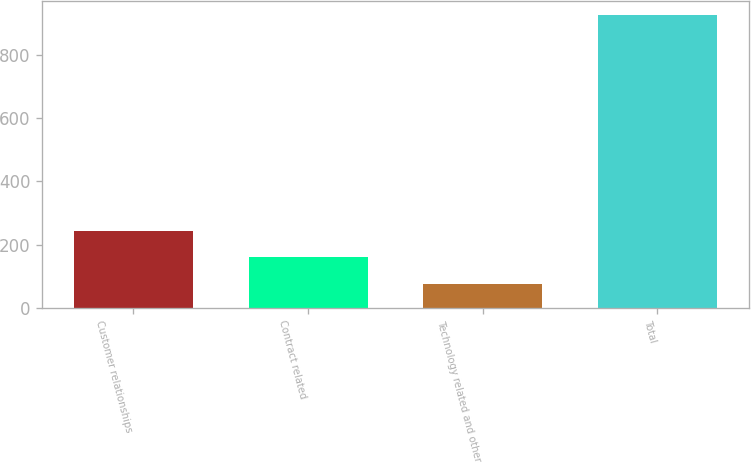Convert chart. <chart><loc_0><loc_0><loc_500><loc_500><bar_chart><fcel>Customer relationships<fcel>Contract related<fcel>Technology related and other<fcel>Total<nl><fcel>244.4<fcel>159.2<fcel>74<fcel>926<nl></chart> 